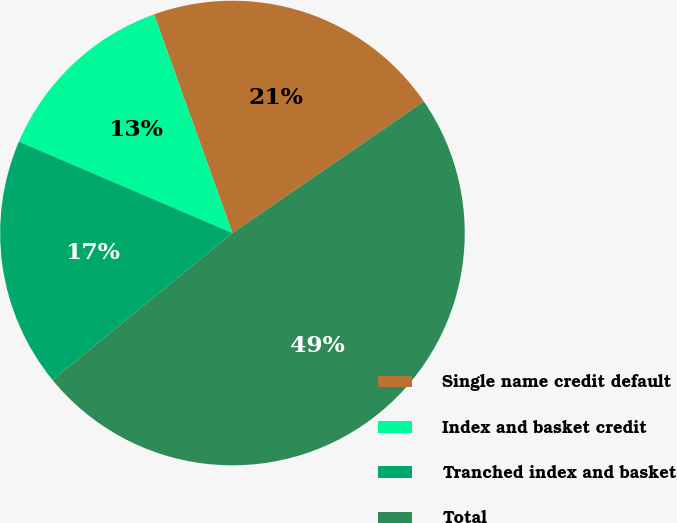<chart> <loc_0><loc_0><loc_500><loc_500><pie_chart><fcel>Single name credit default<fcel>Index and basket credit<fcel>Tranched index and basket<fcel>Total<nl><fcel>20.9%<fcel>13.08%<fcel>17.34%<fcel>48.68%<nl></chart> 